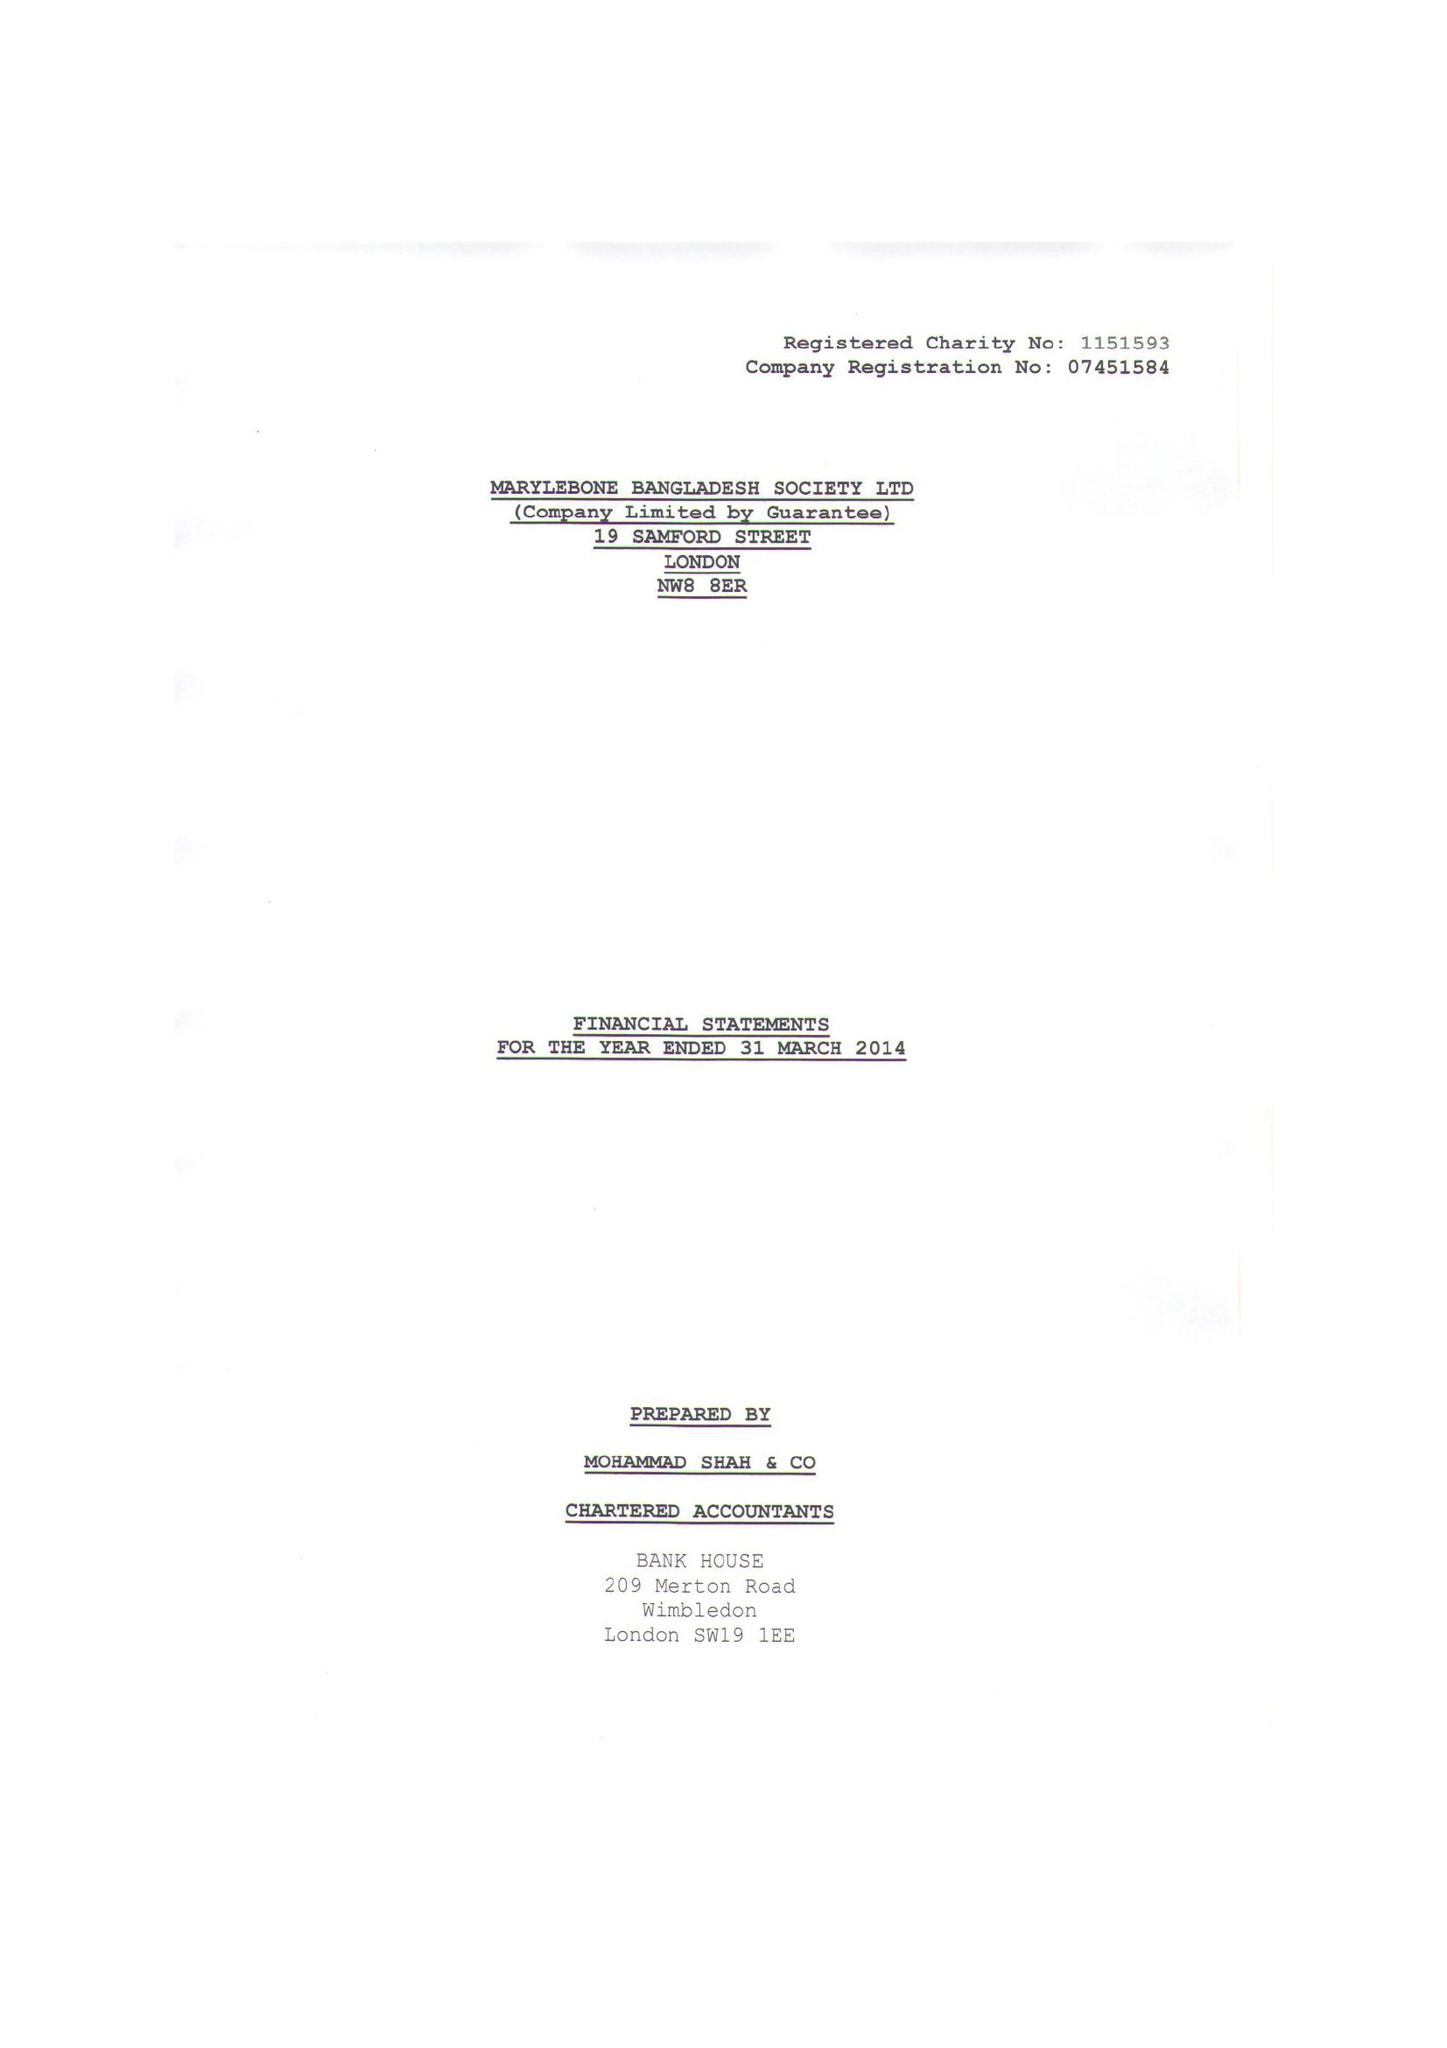What is the value for the income_annually_in_british_pounds?
Answer the question using a single word or phrase. 197389.00 